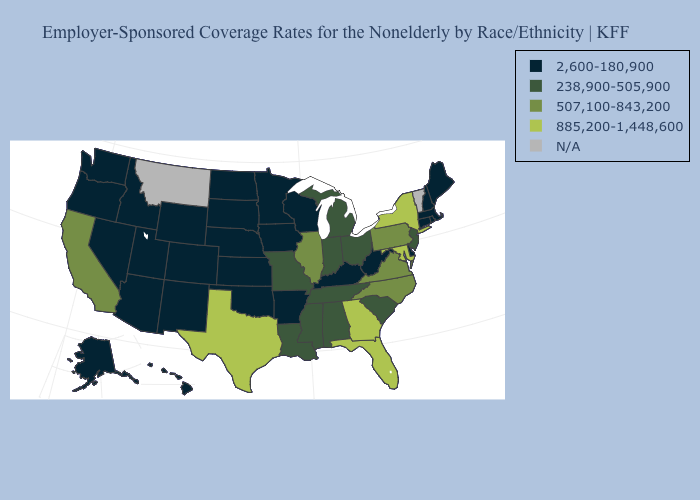Name the states that have a value in the range 238,900-505,900?
Concise answer only. Alabama, Indiana, Louisiana, Michigan, Mississippi, Missouri, New Jersey, Ohio, South Carolina, Tennessee. What is the highest value in states that border Montana?
Give a very brief answer. 2,600-180,900. Name the states that have a value in the range 507,100-843,200?
Keep it brief. California, Illinois, North Carolina, Pennsylvania, Virginia. What is the highest value in the USA?
Be succinct. 885,200-1,448,600. Does New York have the highest value in the USA?
Give a very brief answer. Yes. Name the states that have a value in the range 507,100-843,200?
Short answer required. California, Illinois, North Carolina, Pennsylvania, Virginia. What is the value of Oklahoma?
Give a very brief answer. 2,600-180,900. What is the value of Louisiana?
Write a very short answer. 238,900-505,900. Among the states that border Missouri , which have the highest value?
Short answer required. Illinois. What is the lowest value in states that border Kansas?
Short answer required. 2,600-180,900. What is the lowest value in states that border Texas?
Answer briefly. 2,600-180,900. Among the states that border Rhode Island , which have the lowest value?
Answer briefly. Connecticut, Massachusetts. Name the states that have a value in the range 507,100-843,200?
Give a very brief answer. California, Illinois, North Carolina, Pennsylvania, Virginia. Does California have the highest value in the West?
Quick response, please. Yes. 